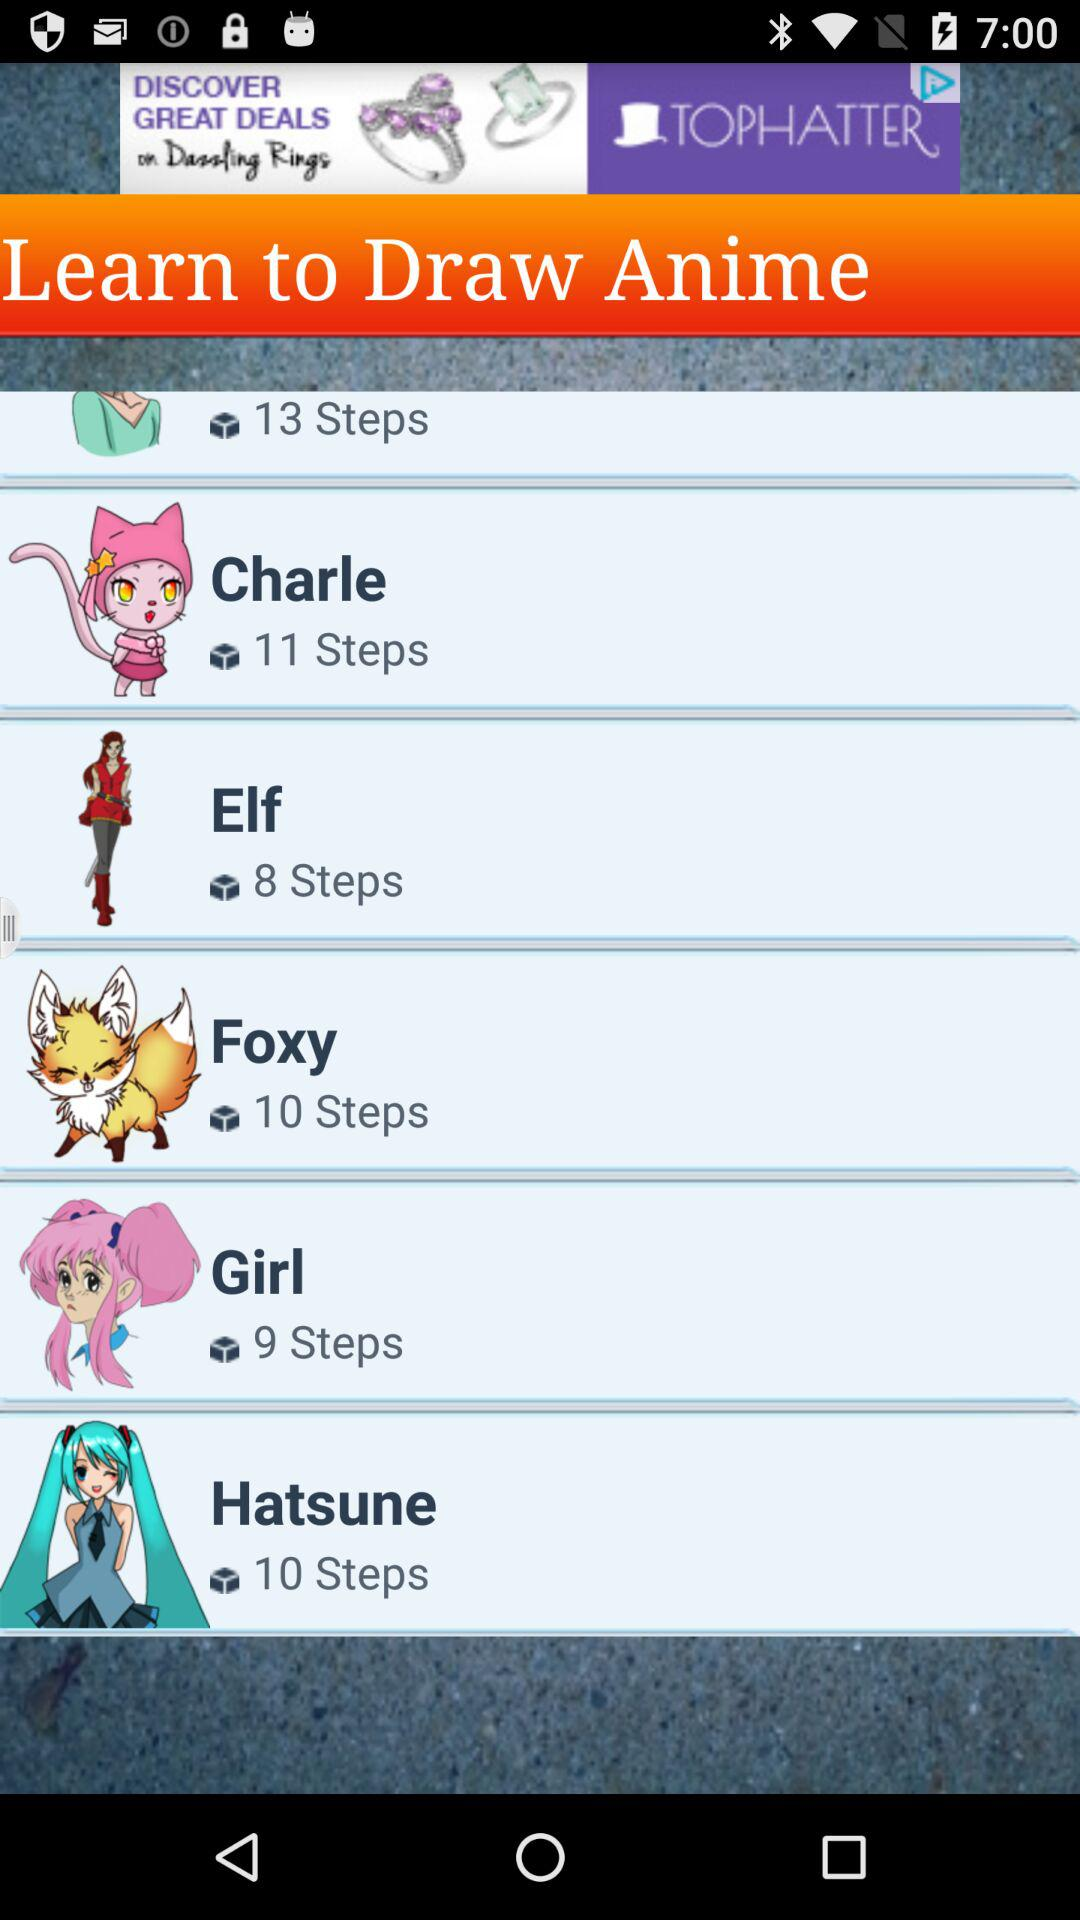How many steps are there for "Elf"? There are 8 steps. 